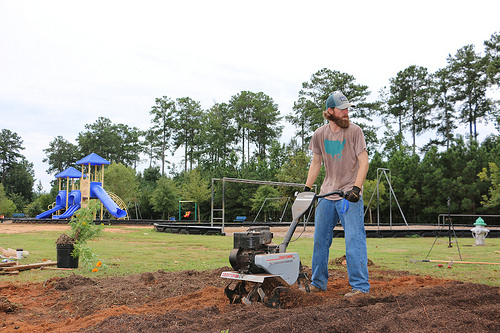<image>
Is the playground behind the man? Yes. From this viewpoint, the playground is positioned behind the man, with the man partially or fully occluding the playground. 